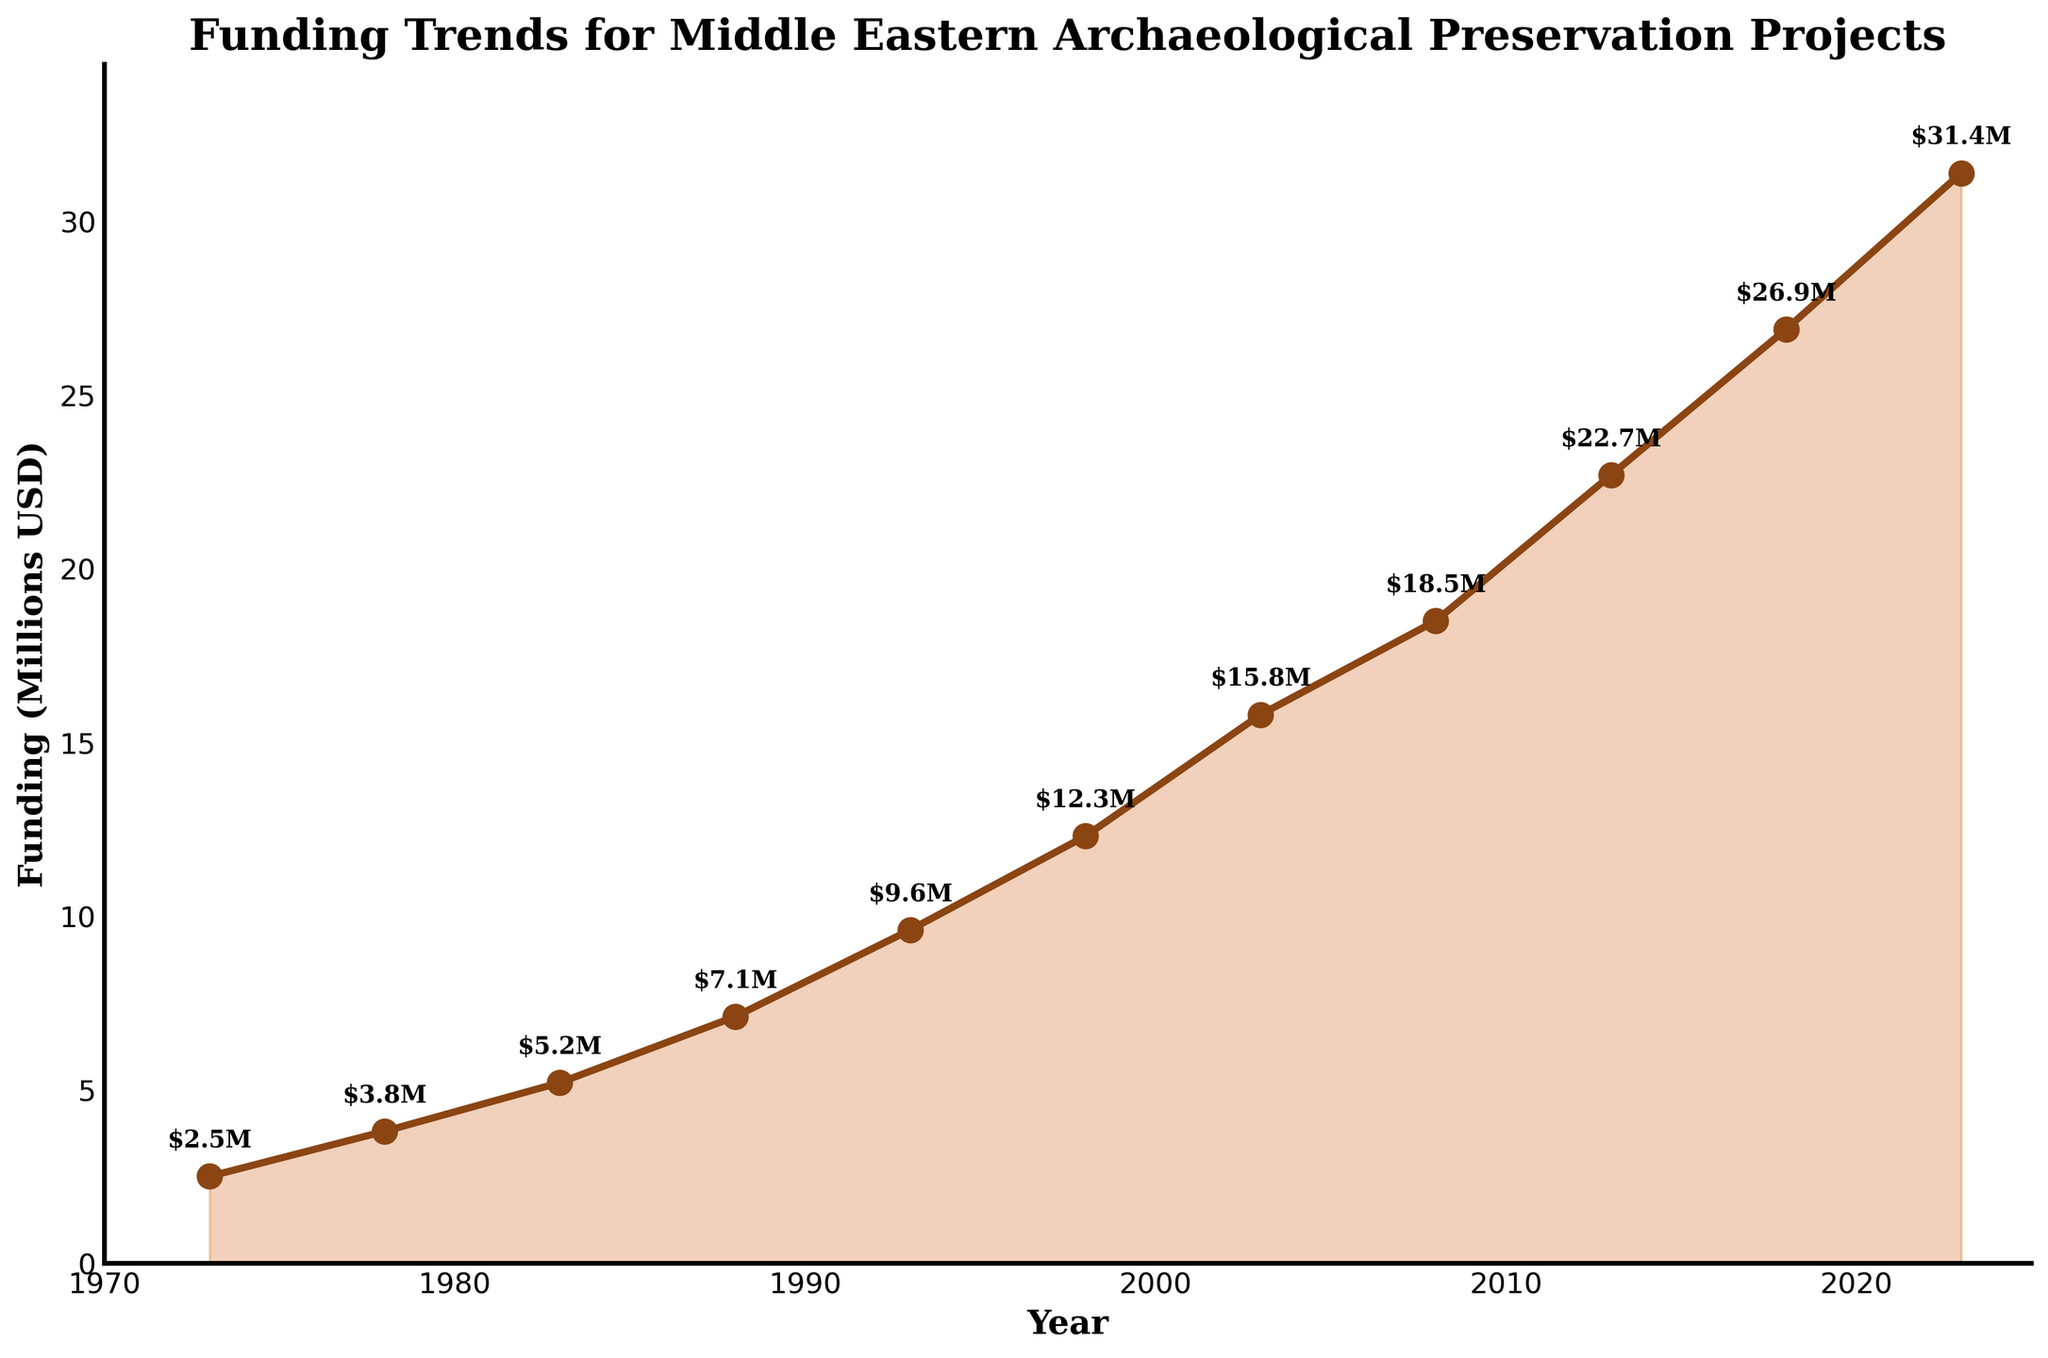what is the overall trend in funding over the last 50 years? The line chart shows that funding for Middle Eastern archaeological preservation projects has generally increased over the last 50 years, rising from $2.5 million in 1973 to $31.4 million in 2023.
Answer: Increasing What was the funding amount in the year 2008? Identify the point on the graph corresponding to the year 2008. The funding amount is marked next to this point: $18.5 million.
Answer: $18.5 million What is the difference in funding between 1978 and 1988? The funding in 1978 was $3.8 million and in 1988 it was $7.1 million. The difference is $7.1 million - $3.8 million = $3.3 million.
Answer: $3.3 million Which year saw the highest funding? The highest marked funding value on the graph is $31.4 million, which corresponds to the year 2023.
Answer: 2023 How much did funding increase from 1998 to 2003? In 1998, the funding was $12.3 million, and in 2003 it increased to $15.8 million. The increase is $15.8 million - $12.3 million = $3.5 million.
Answer: $3.5 million What was the average annual funding for the period 2008 to 2023? Summarize the funding amounts for the given years (2008: $18.5M, 2013: $22.7M, 2018: $26.9M, 2023: $31.4M). The total is $18.5M + $22.7M + $26.9M + $31.4M = $99.5M. There are 4 data points, so the average is $99.5M / 4 = $24.875M.
Answer: $24.875 million By how much did funding increase between the first and last years in the chart? The funding in 1973 was $2.5 million, and in 2023 it is $31.4 million. The increase is $31.4 million - $2.5 million = $28.9 million.
Answer: $28.9 million What was the average funding level in the 1980s? Summarize the funding amounts for the years in the 1980s (1983: $5.2M, 1988: $7.1M). The total is $5.2M + $7.1M = $12.3M. There are 2 data points, so the average is $12.3M / 2 = $6.15M.
Answer: $6.15 million Which period saw the fastest growth in funding? Calculate the growth rate by examining the steepness of the slope in segments of the graph. The steepest segment, which shows the most dramatic rise, is between 2013 ($22.7M) and 2023 ($31.4M), where it increases sharply within just 10 years.
Answer: 2013-2023 